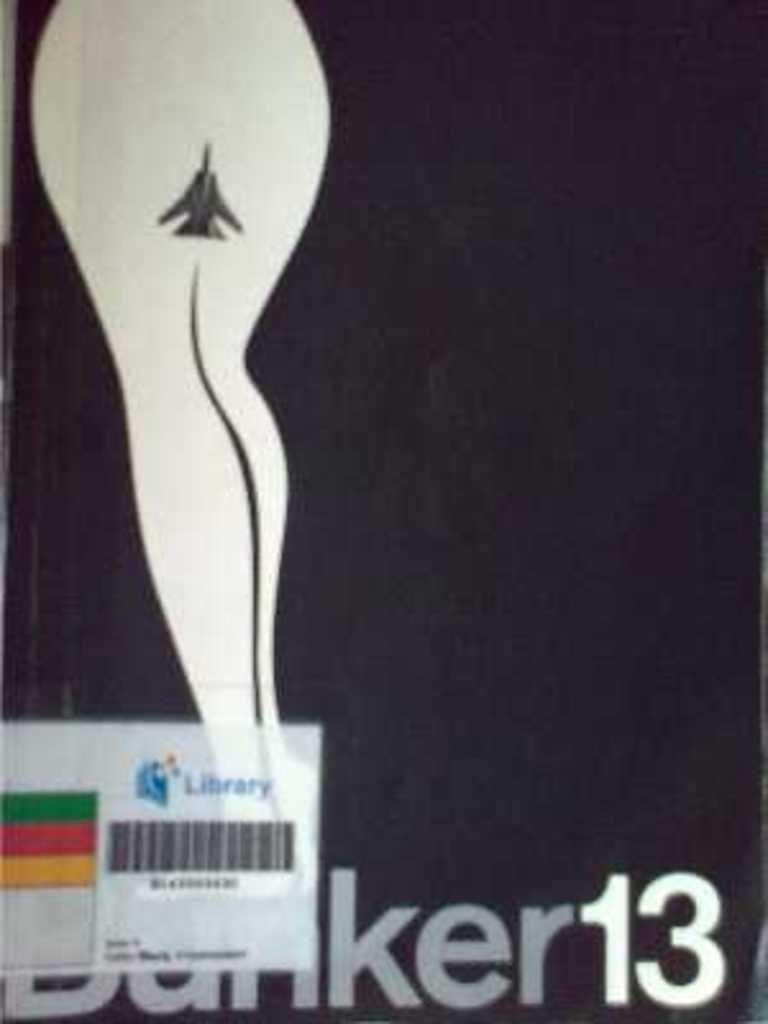In one or two sentences, can you explain what this image depicts? In this image we can see picture of a person's leg and barcode. At the bottom of the image we can see some text. 